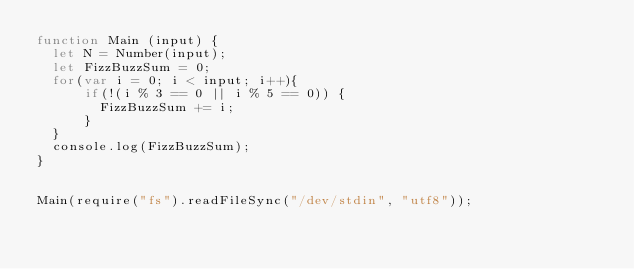<code> <loc_0><loc_0><loc_500><loc_500><_JavaScript_>function Main (input) {
  let N = Number(input);
  let FizzBuzzSum = 0;
  for(var i = 0; i < input; i++){
      if(!(i % 3 == 0 || i % 5 == 0)) {
        FizzBuzzSum += i;
      }
  }
  console.log(FizzBuzzSum);
}
  
  
Main(require("fs").readFileSync("/dev/stdin", "utf8"));
</code> 